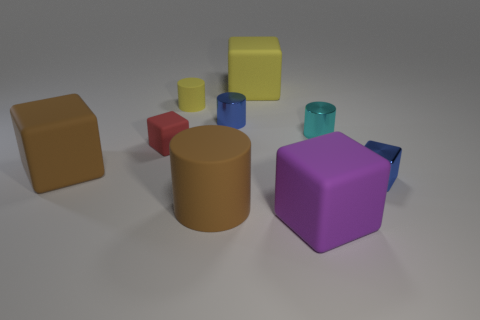Subtract all small blue metal blocks. How many blocks are left? 4 Subtract 2 blocks. How many blocks are left? 3 Subtract all yellow blocks. How many blocks are left? 4 Subtract all purple spheres. How many yellow cylinders are left? 1 Add 1 big brown matte cubes. How many objects exist? 10 Subtract 0 yellow balls. How many objects are left? 9 Subtract all cylinders. How many objects are left? 5 Subtract all yellow cylinders. Subtract all blue balls. How many cylinders are left? 3 Subtract all cyan metal objects. Subtract all tiny blue metallic cylinders. How many objects are left? 7 Add 6 tiny red matte cubes. How many tiny red matte cubes are left? 7 